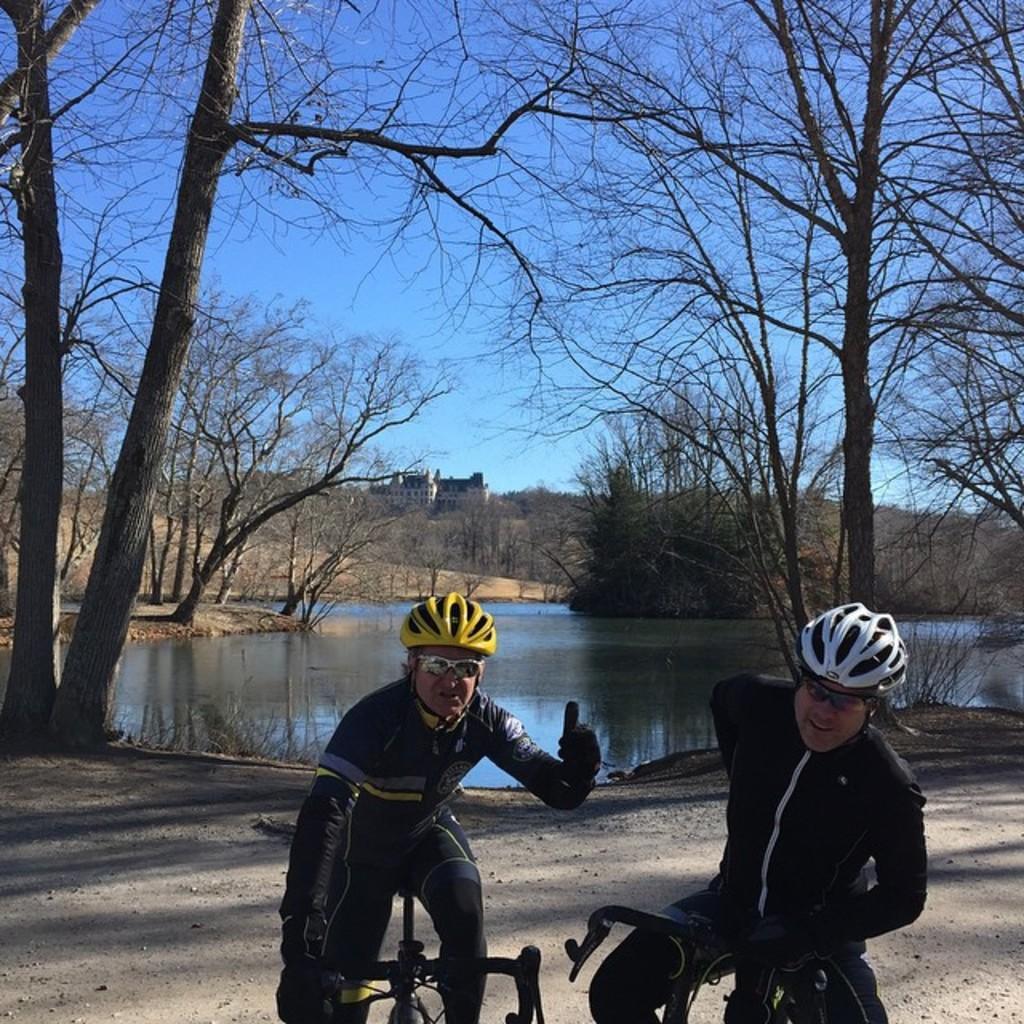Can you describe this image briefly? In this image we can see two persons wearing helmets, goggles and gloves. And they are on cycles. In the background there are trees. Also there is water. And there is building. Also there is sky. 